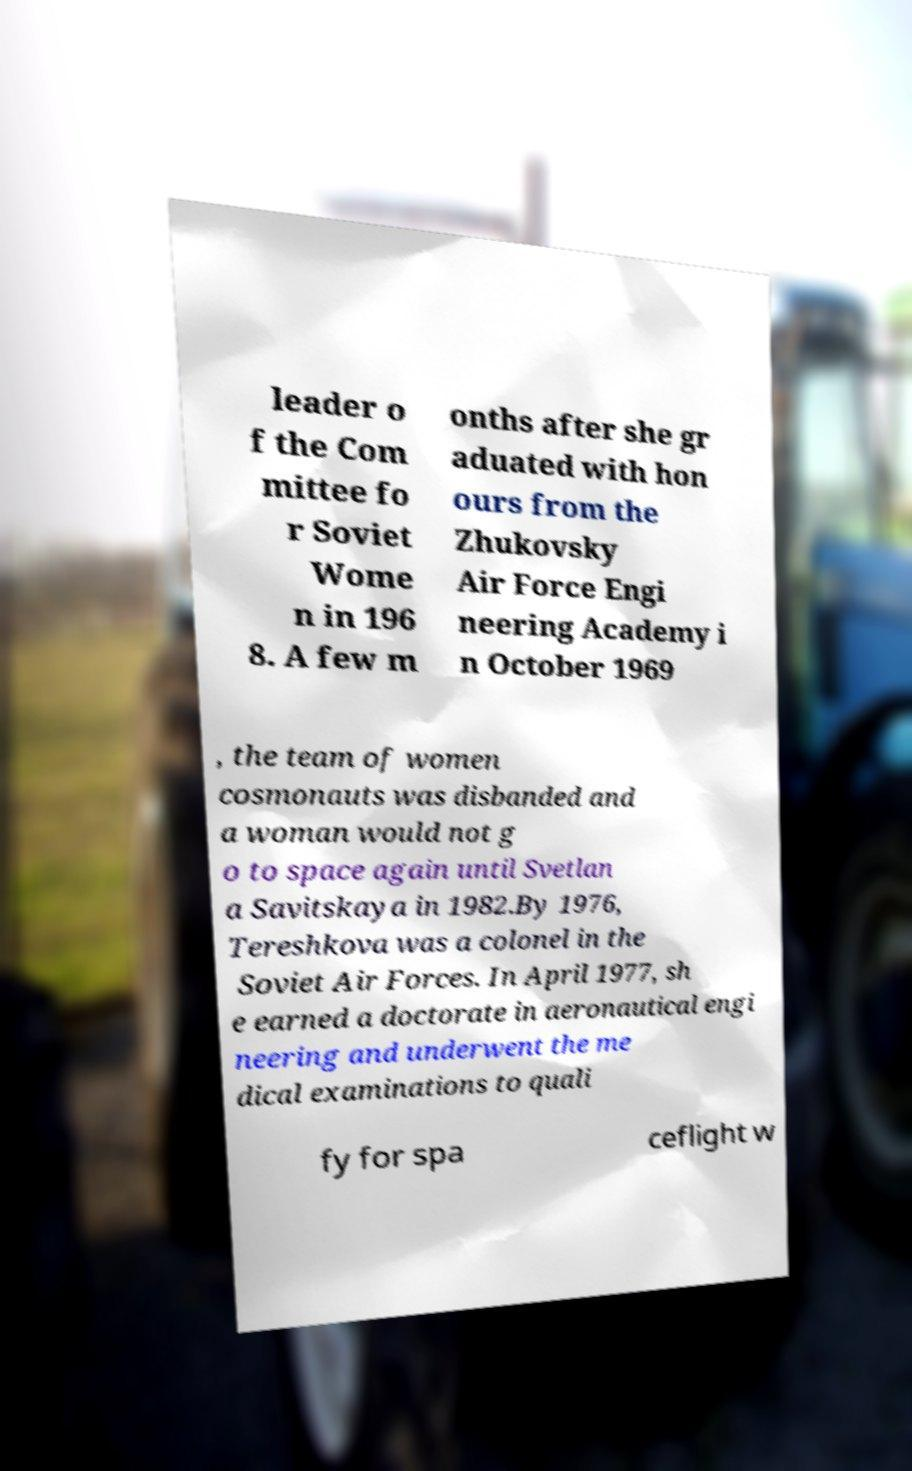Please read and relay the text visible in this image. What does it say? leader o f the Com mittee fo r Soviet Wome n in 196 8. A few m onths after she gr aduated with hon ours from the Zhukovsky Air Force Engi neering Academy i n October 1969 , the team of women cosmonauts was disbanded and a woman would not g o to space again until Svetlan a Savitskaya in 1982.By 1976, Tereshkova was a colonel in the Soviet Air Forces. In April 1977, sh e earned a doctorate in aeronautical engi neering and underwent the me dical examinations to quali fy for spa ceflight w 